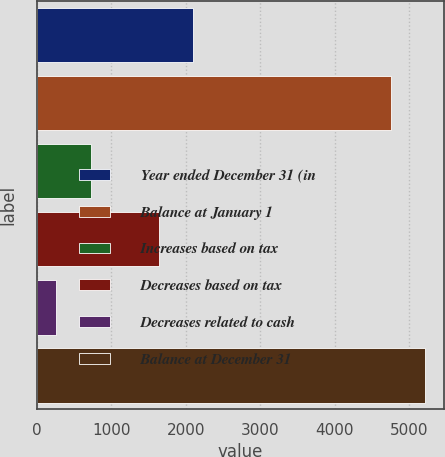Convert chart. <chart><loc_0><loc_0><loc_500><loc_500><bar_chart><fcel>Year ended December 31 (in<fcel>Balance at January 1<fcel>Increases based on tax<fcel>Decreases based on tax<fcel>Decreases related to cash<fcel>Balance at December 31<nl><fcel>2104<fcel>4747<fcel>725.5<fcel>1644.5<fcel>266<fcel>5206.5<nl></chart> 